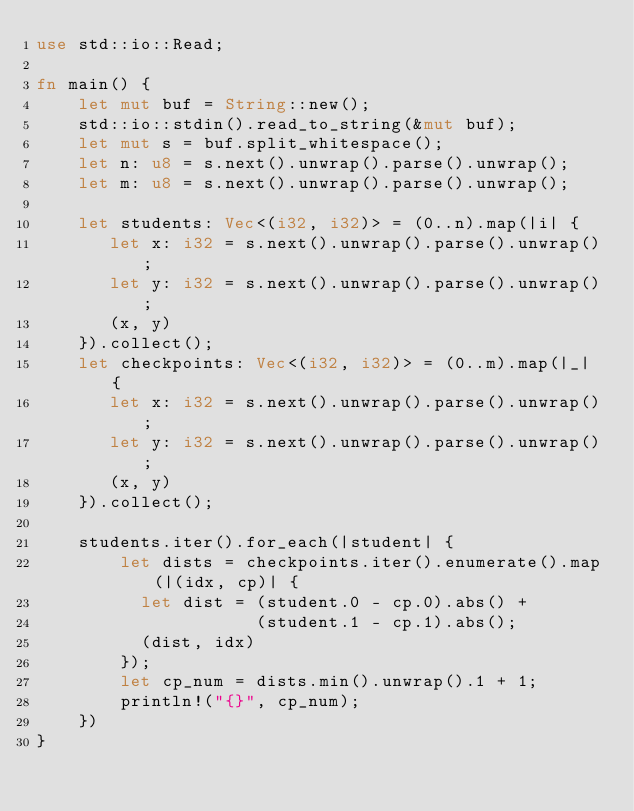<code> <loc_0><loc_0><loc_500><loc_500><_Rust_>use std::io::Read;

fn main() {
    let mut buf = String::new();
    std::io::stdin().read_to_string(&mut buf);
    let mut s = buf.split_whitespace();
    let n: u8 = s.next().unwrap().parse().unwrap();
    let m: u8 = s.next().unwrap().parse().unwrap();

    let students: Vec<(i32, i32)> = (0..n).map(|i| {
       let x: i32 = s.next().unwrap().parse().unwrap();
       let y: i32 = s.next().unwrap().parse().unwrap();
       (x, y)
    }).collect();
    let checkpoints: Vec<(i32, i32)> = (0..m).map(|_| {
       let x: i32 = s.next().unwrap().parse().unwrap();
       let y: i32 = s.next().unwrap().parse().unwrap();
       (x, y)
    }).collect();

    students.iter().for_each(|student| {
        let dists = checkpoints.iter().enumerate().map(|(idx, cp)| {
          let dist = (student.0 - cp.0).abs() +
                     (student.1 - cp.1).abs();
          (dist, idx)
        });
        let cp_num = dists.min().unwrap().1 + 1;
        println!("{}", cp_num);
    })
}
</code> 